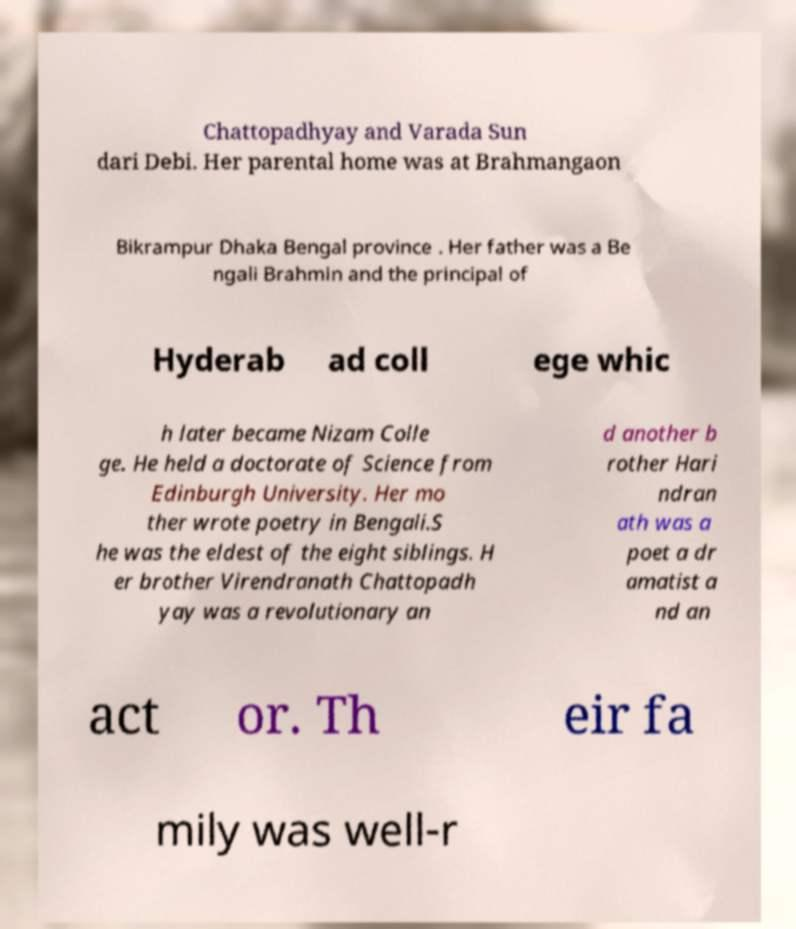Could you extract and type out the text from this image? Chattopadhyay and Varada Sun dari Debi. Her parental home was at Brahmangaon Bikrampur Dhaka Bengal province . Her father was a Be ngali Brahmin and the principal of Hyderab ad coll ege whic h later became Nizam Colle ge. He held a doctorate of Science from Edinburgh University. Her mo ther wrote poetry in Bengali.S he was the eldest of the eight siblings. H er brother Virendranath Chattopadh yay was a revolutionary an d another b rother Hari ndran ath was a poet a dr amatist a nd an act or. Th eir fa mily was well-r 